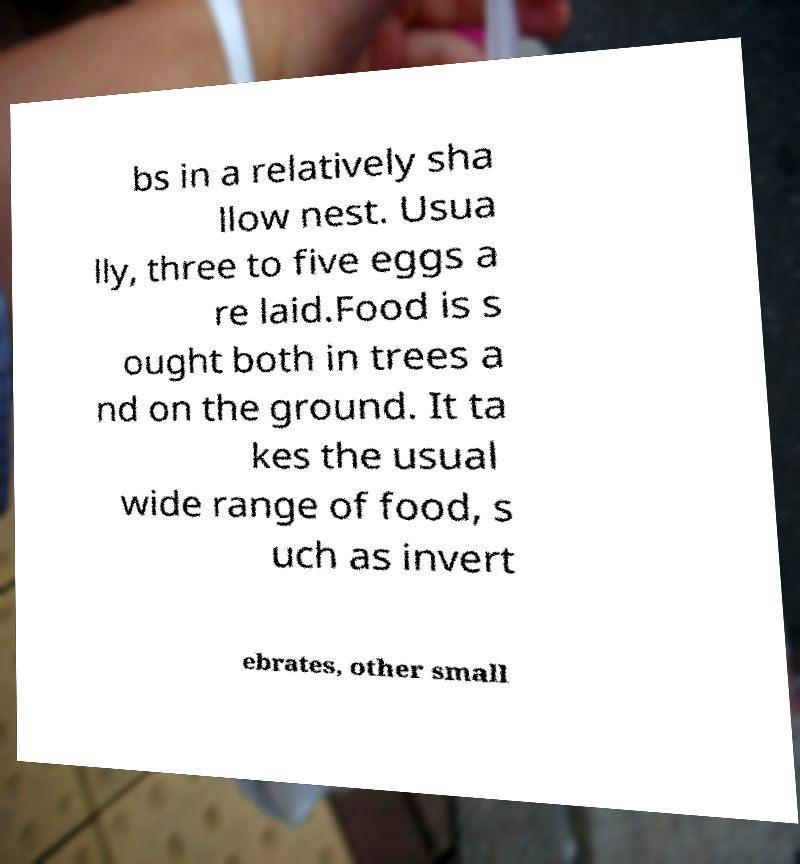Please identify and transcribe the text found in this image. bs in a relatively sha llow nest. Usua lly, three to five eggs a re laid.Food is s ought both in trees a nd on the ground. It ta kes the usual wide range of food, s uch as invert ebrates, other small 